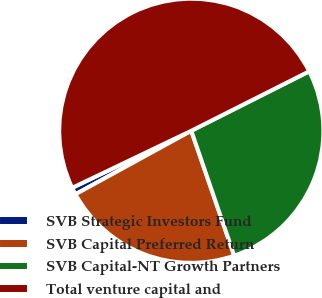Convert chart to OTSL. <chart><loc_0><loc_0><loc_500><loc_500><pie_chart><fcel>SVB Strategic Investors Fund<fcel>SVB Capital Preferred Return<fcel>SVB Capital-NT Growth Partners<fcel>Total venture capital and<nl><fcel>0.87%<fcel>22.29%<fcel>27.17%<fcel>49.68%<nl></chart> 